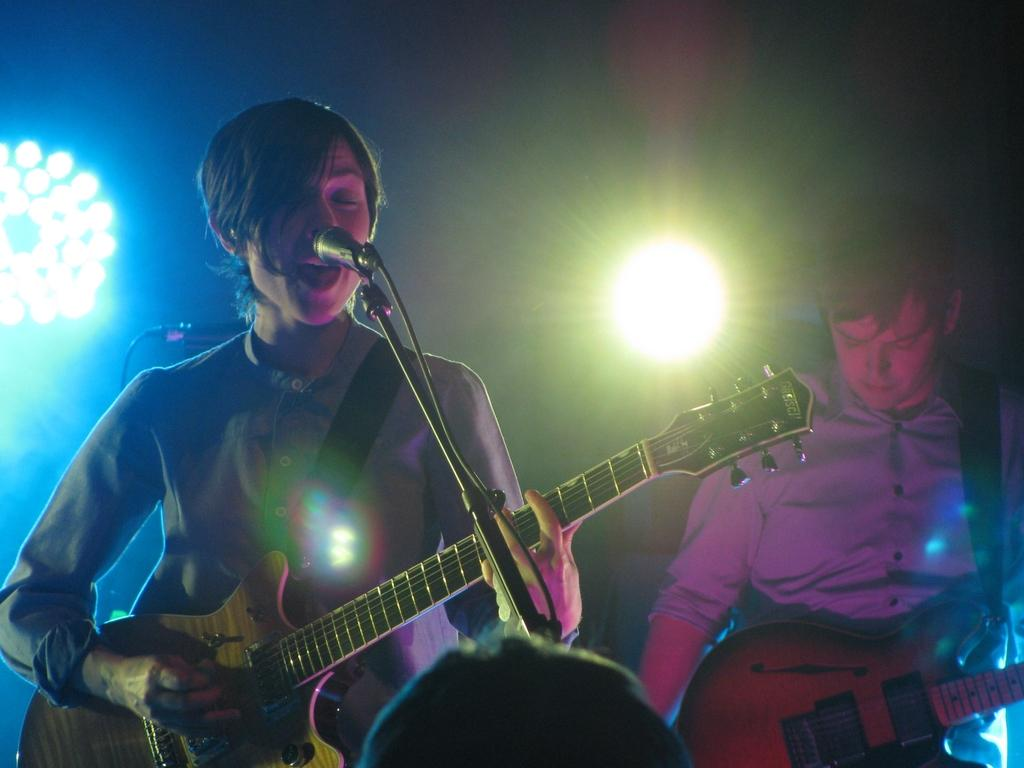What is the woman in the image doing? The woman is singing and playing a guitar. What is the woman's position in relation to the microphone? The woman is in front of a microphone. What is the man in the image doing? The man is playing a guitar. What can be seen in the background of the image? There are lights visible in the background of the image. What type of yam is the woman holding in the image? There is no yam present in the image; the woman is holding a guitar. What knowledge is the man sharing with the audience in the image? There is no indication in the image that the man is sharing any knowledge with an audience. 